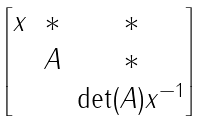Convert formula to latex. <formula><loc_0><loc_0><loc_500><loc_500>\begin{bmatrix} x & * & * \\ & A & * \\ & & \det ( A ) x ^ { - 1 } \end{bmatrix}</formula> 